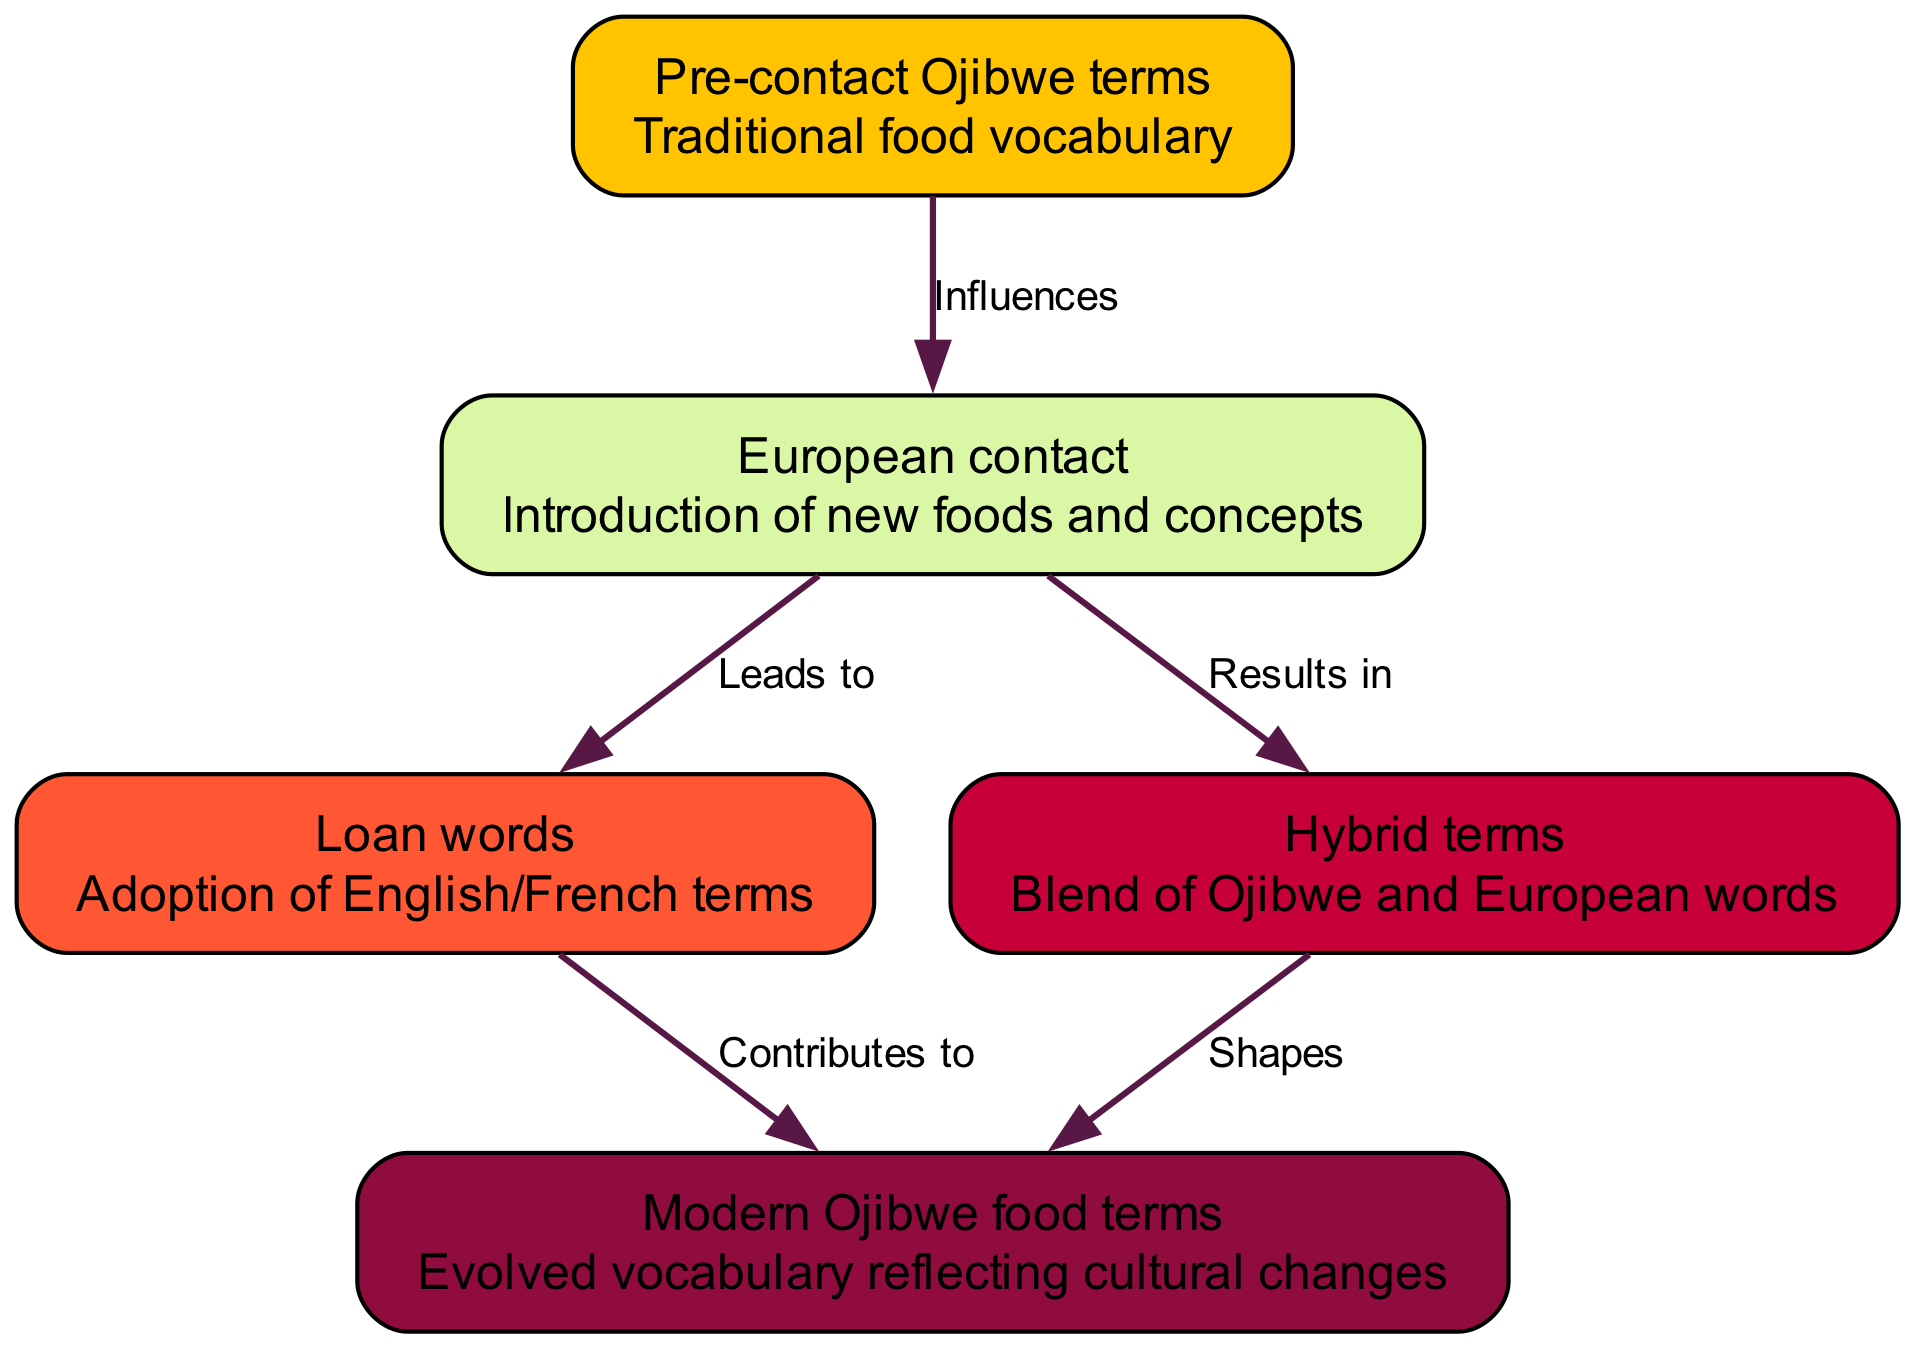What are the two influences from Pre-contact Ojibwe terms? The diagram shows that Pre-contact Ojibwe terms influence European contact, and this relationship is represented by the edge labeled “Influences.”
Answer: European contact How many types of terms are listed in the diagram? The diagram contains five distinct types of terms, which are represented as nodes in it. Counting these nodes gives us the number of types.
Answer: 5 What is the relationship between European contact and Loan words? The diagram indicates that European contact leads to the adoption of Loan words, as shown by the directed edge labeled “Leads to.”
Answer: Leads to Which type of terms shapes modern Ojibwe food terms? The diagram illustrates that Hybrid terms shape modern Ojibwe food terms according to the edge labeled “Shapes.”
Answer: Hybrid terms What aspect of cultural change is reflected in modern Ojibwe food terms? The diagram signifies that modern Ojibwe food terms reflect evolved vocabulary, indicating that language has adapted to cultural changes over time.
Answer: Evolved vocabulary What contributes to modern Ojibwe food terms? The diagram shows that Loan words contribute to modern Ojibwe food terms, as indicated by the edge labeled “Contributes to.”
Answer: Loan words Which element results from European contact aside from Loan words? The diagram specifies that Hybrid terms result from European contact, represented by the edge labeled “Results in.”
Answer: Hybrid terms Which term describes the traditional food vocabulary? In the diagram, the node labeled “Pre-contact Ojibwe terms” specifically describes traditional food vocabulary.
Answer: Pre-contact Ojibwe terms How many edges are present in the diagram? By analyzing the connections in the diagram, we find that there are five edges connecting the different elements together.
Answer: 5 